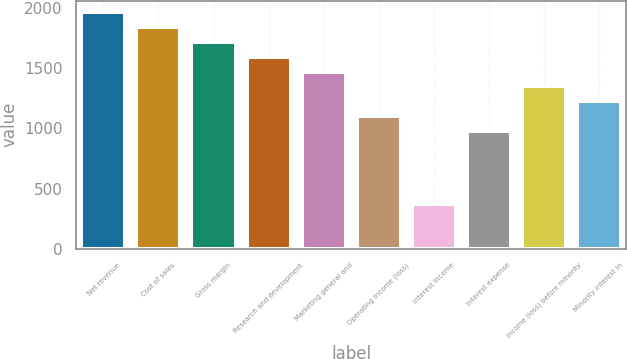Convert chart. <chart><loc_0><loc_0><loc_500><loc_500><bar_chart><fcel>Net revenue<fcel>Cost of sales<fcel>Gross margin<fcel>Research and development<fcel>Marketing general and<fcel>Operating income (loss)<fcel>Interest Income<fcel>Interest expense<fcel>Income (loss) before minority<fcel>Minority interest in<nl><fcel>1963.24<fcel>1840.54<fcel>1717.84<fcel>1595.14<fcel>1472.44<fcel>1104.34<fcel>368.14<fcel>981.64<fcel>1349.74<fcel>1227.04<nl></chart> 